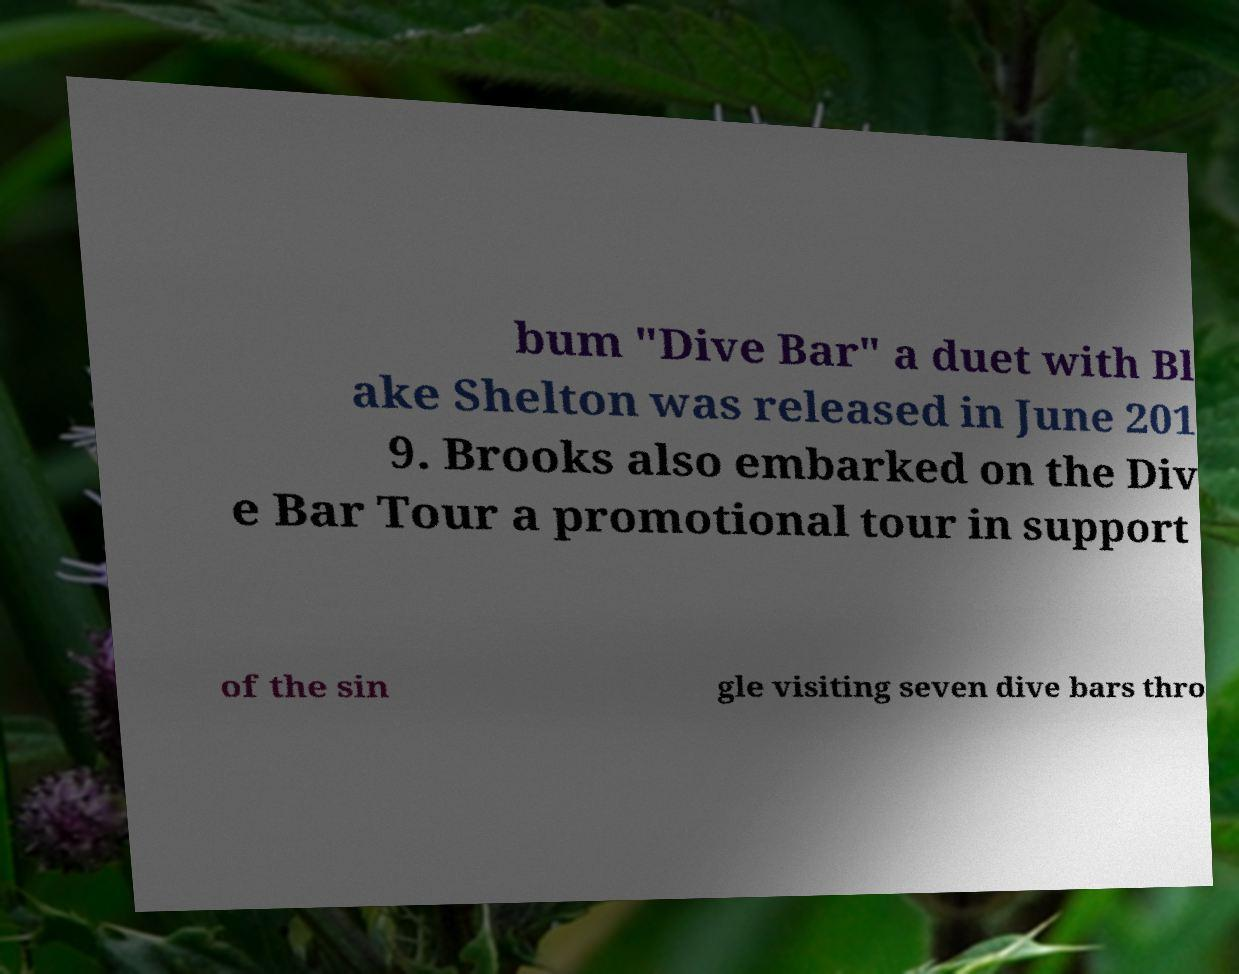I need the written content from this picture converted into text. Can you do that? bum "Dive Bar" a duet with Bl ake Shelton was released in June 201 9. Brooks also embarked on the Div e Bar Tour a promotional tour in support of the sin gle visiting seven dive bars thro 